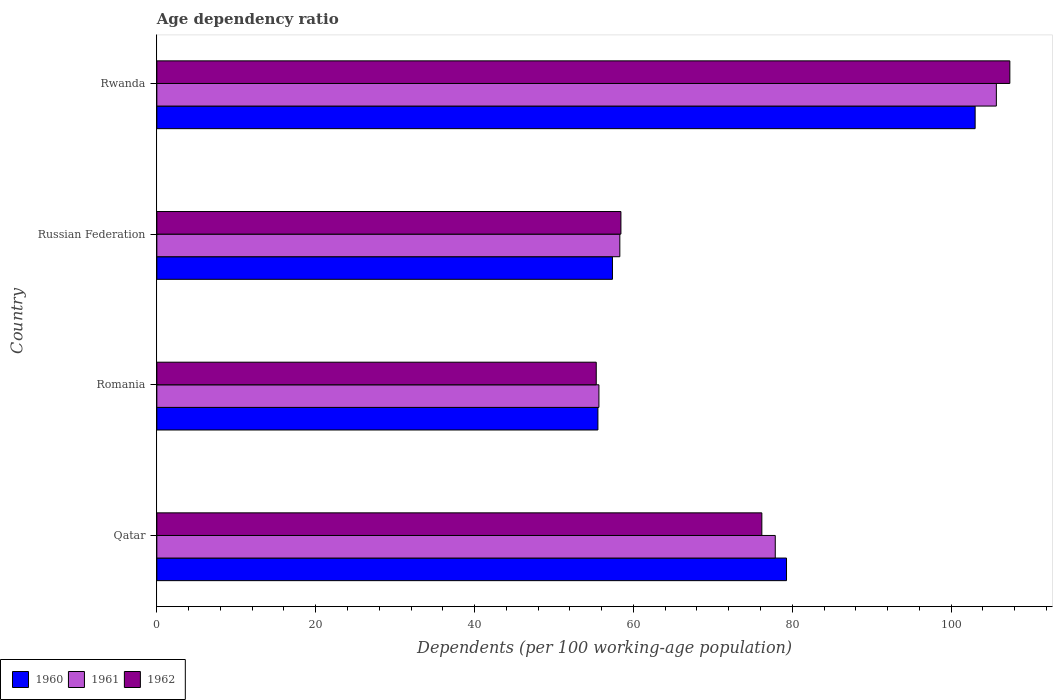How many different coloured bars are there?
Offer a very short reply. 3. How many groups of bars are there?
Provide a succinct answer. 4. How many bars are there on the 3rd tick from the bottom?
Your response must be concise. 3. What is the label of the 3rd group of bars from the top?
Make the answer very short. Romania. In how many cases, is the number of bars for a given country not equal to the number of legend labels?
Keep it short and to the point. 0. What is the age dependency ratio in in 1960 in Qatar?
Make the answer very short. 79.28. Across all countries, what is the maximum age dependency ratio in in 1961?
Your response must be concise. 105.69. Across all countries, what is the minimum age dependency ratio in in 1960?
Offer a very short reply. 55.53. In which country was the age dependency ratio in in 1962 maximum?
Make the answer very short. Rwanda. In which country was the age dependency ratio in in 1962 minimum?
Give a very brief answer. Romania. What is the total age dependency ratio in in 1961 in the graph?
Offer a very short reply. 297.5. What is the difference between the age dependency ratio in in 1962 in Qatar and that in Rwanda?
Your answer should be very brief. -31.22. What is the difference between the age dependency ratio in in 1961 in Romania and the age dependency ratio in in 1962 in Qatar?
Offer a terse response. -20.51. What is the average age dependency ratio in in 1960 per country?
Make the answer very short. 73.8. What is the difference between the age dependency ratio in in 1961 and age dependency ratio in in 1962 in Qatar?
Your answer should be compact. 1.69. What is the ratio of the age dependency ratio in in 1960 in Qatar to that in Romania?
Offer a very short reply. 1.43. Is the age dependency ratio in in 1962 in Qatar less than that in Rwanda?
Offer a very short reply. Yes. Is the difference between the age dependency ratio in in 1961 in Qatar and Rwanda greater than the difference between the age dependency ratio in in 1962 in Qatar and Rwanda?
Make the answer very short. Yes. What is the difference between the highest and the second highest age dependency ratio in in 1960?
Ensure brevity in your answer.  23.75. What is the difference between the highest and the lowest age dependency ratio in in 1961?
Offer a terse response. 50.04. Is the sum of the age dependency ratio in in 1961 in Romania and Russian Federation greater than the maximum age dependency ratio in in 1962 across all countries?
Offer a very short reply. Yes. What does the 1st bar from the bottom in Qatar represents?
Provide a succinct answer. 1960. Is it the case that in every country, the sum of the age dependency ratio in in 1961 and age dependency ratio in in 1960 is greater than the age dependency ratio in in 1962?
Offer a very short reply. Yes. Are all the bars in the graph horizontal?
Give a very brief answer. Yes. How many countries are there in the graph?
Offer a terse response. 4. What is the difference between two consecutive major ticks on the X-axis?
Make the answer very short. 20. Are the values on the major ticks of X-axis written in scientific E-notation?
Provide a short and direct response. No. Does the graph contain any zero values?
Provide a succinct answer. No. Does the graph contain grids?
Provide a succinct answer. No. Where does the legend appear in the graph?
Your answer should be very brief. Bottom left. How are the legend labels stacked?
Offer a terse response. Horizontal. What is the title of the graph?
Offer a very short reply. Age dependency ratio. Does "1999" appear as one of the legend labels in the graph?
Provide a succinct answer. No. What is the label or title of the X-axis?
Your answer should be very brief. Dependents (per 100 working-age population). What is the Dependents (per 100 working-age population) of 1960 in Qatar?
Make the answer very short. 79.28. What is the Dependents (per 100 working-age population) of 1961 in Qatar?
Offer a very short reply. 77.86. What is the Dependents (per 100 working-age population) in 1962 in Qatar?
Your response must be concise. 76.17. What is the Dependents (per 100 working-age population) of 1960 in Romania?
Your response must be concise. 55.53. What is the Dependents (per 100 working-age population) in 1961 in Romania?
Offer a very short reply. 55.66. What is the Dependents (per 100 working-age population) in 1962 in Romania?
Your answer should be compact. 55.32. What is the Dependents (per 100 working-age population) of 1960 in Russian Federation?
Provide a succinct answer. 57.36. What is the Dependents (per 100 working-age population) of 1961 in Russian Federation?
Your answer should be compact. 58.29. What is the Dependents (per 100 working-age population) of 1962 in Russian Federation?
Your answer should be compact. 58.43. What is the Dependents (per 100 working-age population) of 1960 in Rwanda?
Your response must be concise. 103.02. What is the Dependents (per 100 working-age population) in 1961 in Rwanda?
Your answer should be compact. 105.69. What is the Dependents (per 100 working-age population) of 1962 in Rwanda?
Your answer should be compact. 107.39. Across all countries, what is the maximum Dependents (per 100 working-age population) in 1960?
Ensure brevity in your answer.  103.02. Across all countries, what is the maximum Dependents (per 100 working-age population) in 1961?
Offer a very short reply. 105.69. Across all countries, what is the maximum Dependents (per 100 working-age population) of 1962?
Ensure brevity in your answer.  107.39. Across all countries, what is the minimum Dependents (per 100 working-age population) of 1960?
Your answer should be very brief. 55.53. Across all countries, what is the minimum Dependents (per 100 working-age population) in 1961?
Offer a very short reply. 55.66. Across all countries, what is the minimum Dependents (per 100 working-age population) of 1962?
Your answer should be very brief. 55.32. What is the total Dependents (per 100 working-age population) of 1960 in the graph?
Keep it short and to the point. 295.19. What is the total Dependents (per 100 working-age population) in 1961 in the graph?
Ensure brevity in your answer.  297.5. What is the total Dependents (per 100 working-age population) of 1962 in the graph?
Provide a short and direct response. 297.31. What is the difference between the Dependents (per 100 working-age population) of 1960 in Qatar and that in Romania?
Provide a succinct answer. 23.75. What is the difference between the Dependents (per 100 working-age population) in 1961 in Qatar and that in Romania?
Your response must be concise. 22.2. What is the difference between the Dependents (per 100 working-age population) of 1962 in Qatar and that in Romania?
Ensure brevity in your answer.  20.85. What is the difference between the Dependents (per 100 working-age population) in 1960 in Qatar and that in Russian Federation?
Ensure brevity in your answer.  21.92. What is the difference between the Dependents (per 100 working-age population) in 1961 in Qatar and that in Russian Federation?
Ensure brevity in your answer.  19.57. What is the difference between the Dependents (per 100 working-age population) in 1962 in Qatar and that in Russian Federation?
Your answer should be compact. 17.74. What is the difference between the Dependents (per 100 working-age population) in 1960 in Qatar and that in Rwanda?
Keep it short and to the point. -23.75. What is the difference between the Dependents (per 100 working-age population) in 1961 in Qatar and that in Rwanda?
Provide a succinct answer. -27.83. What is the difference between the Dependents (per 100 working-age population) in 1962 in Qatar and that in Rwanda?
Your answer should be compact. -31.22. What is the difference between the Dependents (per 100 working-age population) in 1960 in Romania and that in Russian Federation?
Provide a succinct answer. -1.83. What is the difference between the Dependents (per 100 working-age population) in 1961 in Romania and that in Russian Federation?
Your answer should be very brief. -2.63. What is the difference between the Dependents (per 100 working-age population) in 1962 in Romania and that in Russian Federation?
Offer a terse response. -3.11. What is the difference between the Dependents (per 100 working-age population) of 1960 in Romania and that in Rwanda?
Make the answer very short. -47.49. What is the difference between the Dependents (per 100 working-age population) of 1961 in Romania and that in Rwanda?
Make the answer very short. -50.04. What is the difference between the Dependents (per 100 working-age population) of 1962 in Romania and that in Rwanda?
Make the answer very short. -52.07. What is the difference between the Dependents (per 100 working-age population) of 1960 in Russian Federation and that in Rwanda?
Offer a terse response. -45.66. What is the difference between the Dependents (per 100 working-age population) in 1961 in Russian Federation and that in Rwanda?
Keep it short and to the point. -47.4. What is the difference between the Dependents (per 100 working-age population) in 1962 in Russian Federation and that in Rwanda?
Your answer should be compact. -48.96. What is the difference between the Dependents (per 100 working-age population) of 1960 in Qatar and the Dependents (per 100 working-age population) of 1961 in Romania?
Your response must be concise. 23.62. What is the difference between the Dependents (per 100 working-age population) in 1960 in Qatar and the Dependents (per 100 working-age population) in 1962 in Romania?
Provide a succinct answer. 23.96. What is the difference between the Dependents (per 100 working-age population) in 1961 in Qatar and the Dependents (per 100 working-age population) in 1962 in Romania?
Ensure brevity in your answer.  22.54. What is the difference between the Dependents (per 100 working-age population) in 1960 in Qatar and the Dependents (per 100 working-age population) in 1961 in Russian Federation?
Make the answer very short. 20.99. What is the difference between the Dependents (per 100 working-age population) of 1960 in Qatar and the Dependents (per 100 working-age population) of 1962 in Russian Federation?
Make the answer very short. 20.85. What is the difference between the Dependents (per 100 working-age population) of 1961 in Qatar and the Dependents (per 100 working-age population) of 1962 in Russian Federation?
Keep it short and to the point. 19.43. What is the difference between the Dependents (per 100 working-age population) in 1960 in Qatar and the Dependents (per 100 working-age population) in 1961 in Rwanda?
Offer a terse response. -26.42. What is the difference between the Dependents (per 100 working-age population) in 1960 in Qatar and the Dependents (per 100 working-age population) in 1962 in Rwanda?
Keep it short and to the point. -28.12. What is the difference between the Dependents (per 100 working-age population) in 1961 in Qatar and the Dependents (per 100 working-age population) in 1962 in Rwanda?
Your response must be concise. -29.53. What is the difference between the Dependents (per 100 working-age population) of 1960 in Romania and the Dependents (per 100 working-age population) of 1961 in Russian Federation?
Keep it short and to the point. -2.76. What is the difference between the Dependents (per 100 working-age population) of 1960 in Romania and the Dependents (per 100 working-age population) of 1962 in Russian Federation?
Your response must be concise. -2.9. What is the difference between the Dependents (per 100 working-age population) of 1961 in Romania and the Dependents (per 100 working-age population) of 1962 in Russian Federation?
Provide a succinct answer. -2.77. What is the difference between the Dependents (per 100 working-age population) of 1960 in Romania and the Dependents (per 100 working-age population) of 1961 in Rwanda?
Give a very brief answer. -50.17. What is the difference between the Dependents (per 100 working-age population) in 1960 in Romania and the Dependents (per 100 working-age population) in 1962 in Rwanda?
Provide a short and direct response. -51.86. What is the difference between the Dependents (per 100 working-age population) of 1961 in Romania and the Dependents (per 100 working-age population) of 1962 in Rwanda?
Provide a succinct answer. -51.73. What is the difference between the Dependents (per 100 working-age population) of 1960 in Russian Federation and the Dependents (per 100 working-age population) of 1961 in Rwanda?
Your answer should be compact. -48.33. What is the difference between the Dependents (per 100 working-age population) of 1960 in Russian Federation and the Dependents (per 100 working-age population) of 1962 in Rwanda?
Offer a terse response. -50.03. What is the difference between the Dependents (per 100 working-age population) of 1961 in Russian Federation and the Dependents (per 100 working-age population) of 1962 in Rwanda?
Ensure brevity in your answer.  -49.1. What is the average Dependents (per 100 working-age population) of 1960 per country?
Give a very brief answer. 73.8. What is the average Dependents (per 100 working-age population) in 1961 per country?
Provide a succinct answer. 74.37. What is the average Dependents (per 100 working-age population) in 1962 per country?
Your answer should be compact. 74.33. What is the difference between the Dependents (per 100 working-age population) of 1960 and Dependents (per 100 working-age population) of 1961 in Qatar?
Keep it short and to the point. 1.42. What is the difference between the Dependents (per 100 working-age population) in 1960 and Dependents (per 100 working-age population) in 1962 in Qatar?
Your answer should be very brief. 3.11. What is the difference between the Dependents (per 100 working-age population) in 1961 and Dependents (per 100 working-age population) in 1962 in Qatar?
Your answer should be very brief. 1.69. What is the difference between the Dependents (per 100 working-age population) of 1960 and Dependents (per 100 working-age population) of 1961 in Romania?
Keep it short and to the point. -0.13. What is the difference between the Dependents (per 100 working-age population) of 1960 and Dependents (per 100 working-age population) of 1962 in Romania?
Make the answer very short. 0.21. What is the difference between the Dependents (per 100 working-age population) in 1961 and Dependents (per 100 working-age population) in 1962 in Romania?
Keep it short and to the point. 0.34. What is the difference between the Dependents (per 100 working-age population) of 1960 and Dependents (per 100 working-age population) of 1961 in Russian Federation?
Ensure brevity in your answer.  -0.93. What is the difference between the Dependents (per 100 working-age population) of 1960 and Dependents (per 100 working-age population) of 1962 in Russian Federation?
Your answer should be very brief. -1.07. What is the difference between the Dependents (per 100 working-age population) of 1961 and Dependents (per 100 working-age population) of 1962 in Russian Federation?
Provide a short and direct response. -0.14. What is the difference between the Dependents (per 100 working-age population) of 1960 and Dependents (per 100 working-age population) of 1961 in Rwanda?
Provide a succinct answer. -2.67. What is the difference between the Dependents (per 100 working-age population) of 1960 and Dependents (per 100 working-age population) of 1962 in Rwanda?
Ensure brevity in your answer.  -4.37. What is the difference between the Dependents (per 100 working-age population) in 1961 and Dependents (per 100 working-age population) in 1962 in Rwanda?
Give a very brief answer. -1.7. What is the ratio of the Dependents (per 100 working-age population) of 1960 in Qatar to that in Romania?
Provide a short and direct response. 1.43. What is the ratio of the Dependents (per 100 working-age population) of 1961 in Qatar to that in Romania?
Your response must be concise. 1.4. What is the ratio of the Dependents (per 100 working-age population) of 1962 in Qatar to that in Romania?
Keep it short and to the point. 1.38. What is the ratio of the Dependents (per 100 working-age population) in 1960 in Qatar to that in Russian Federation?
Make the answer very short. 1.38. What is the ratio of the Dependents (per 100 working-age population) of 1961 in Qatar to that in Russian Federation?
Keep it short and to the point. 1.34. What is the ratio of the Dependents (per 100 working-age population) in 1962 in Qatar to that in Russian Federation?
Give a very brief answer. 1.3. What is the ratio of the Dependents (per 100 working-age population) of 1960 in Qatar to that in Rwanda?
Ensure brevity in your answer.  0.77. What is the ratio of the Dependents (per 100 working-age population) in 1961 in Qatar to that in Rwanda?
Your answer should be very brief. 0.74. What is the ratio of the Dependents (per 100 working-age population) of 1962 in Qatar to that in Rwanda?
Offer a terse response. 0.71. What is the ratio of the Dependents (per 100 working-age population) of 1960 in Romania to that in Russian Federation?
Provide a short and direct response. 0.97. What is the ratio of the Dependents (per 100 working-age population) of 1961 in Romania to that in Russian Federation?
Provide a succinct answer. 0.95. What is the ratio of the Dependents (per 100 working-age population) of 1962 in Romania to that in Russian Federation?
Offer a terse response. 0.95. What is the ratio of the Dependents (per 100 working-age population) of 1960 in Romania to that in Rwanda?
Provide a short and direct response. 0.54. What is the ratio of the Dependents (per 100 working-age population) of 1961 in Romania to that in Rwanda?
Give a very brief answer. 0.53. What is the ratio of the Dependents (per 100 working-age population) of 1962 in Romania to that in Rwanda?
Ensure brevity in your answer.  0.52. What is the ratio of the Dependents (per 100 working-age population) in 1960 in Russian Federation to that in Rwanda?
Provide a succinct answer. 0.56. What is the ratio of the Dependents (per 100 working-age population) of 1961 in Russian Federation to that in Rwanda?
Give a very brief answer. 0.55. What is the ratio of the Dependents (per 100 working-age population) of 1962 in Russian Federation to that in Rwanda?
Your answer should be compact. 0.54. What is the difference between the highest and the second highest Dependents (per 100 working-age population) of 1960?
Your answer should be very brief. 23.75. What is the difference between the highest and the second highest Dependents (per 100 working-age population) of 1961?
Your answer should be very brief. 27.83. What is the difference between the highest and the second highest Dependents (per 100 working-age population) of 1962?
Give a very brief answer. 31.22. What is the difference between the highest and the lowest Dependents (per 100 working-age population) in 1960?
Your answer should be compact. 47.49. What is the difference between the highest and the lowest Dependents (per 100 working-age population) in 1961?
Give a very brief answer. 50.04. What is the difference between the highest and the lowest Dependents (per 100 working-age population) of 1962?
Offer a very short reply. 52.07. 